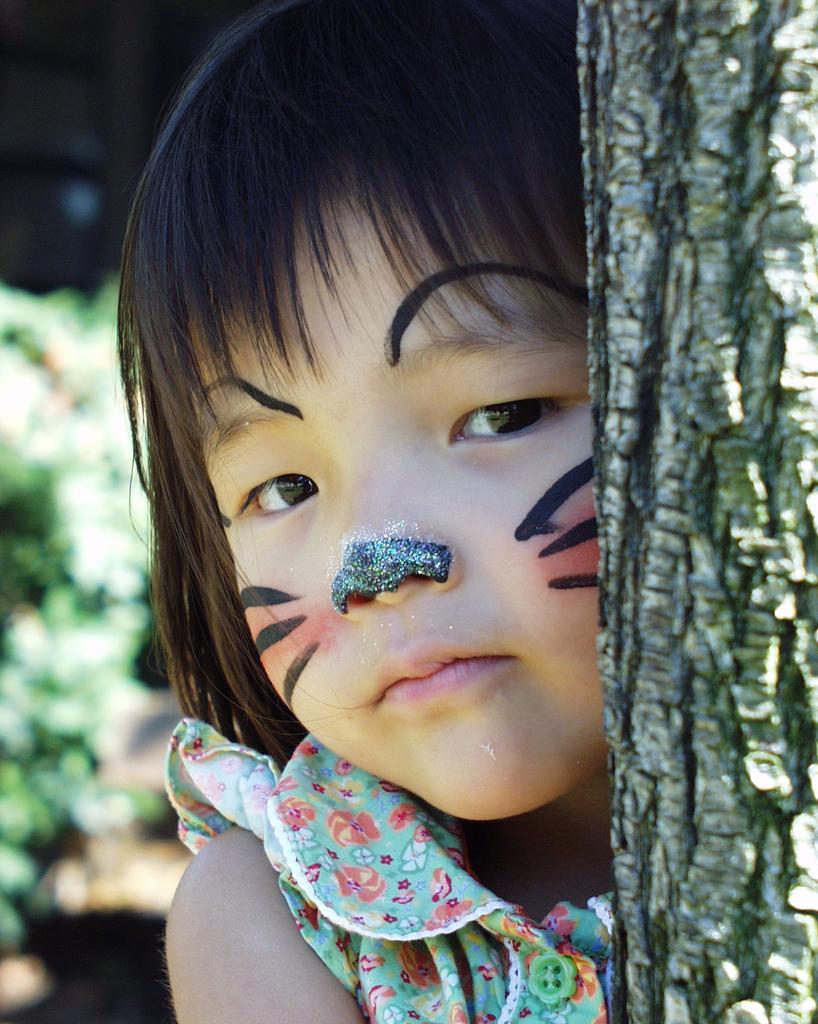How would you summarize this image in a sentence or two? In this picture I can see a girl wearing face painting, side there is a tree trunk. 